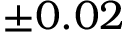<formula> <loc_0><loc_0><loc_500><loc_500>\pm 0 . 0 2</formula> 